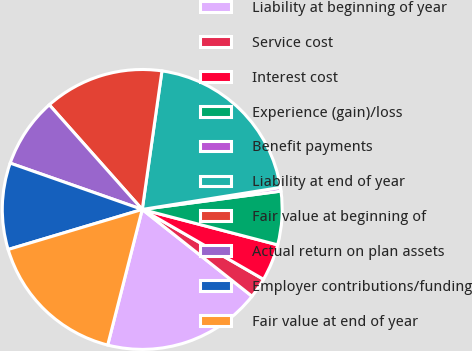Convert chart. <chart><loc_0><loc_0><loc_500><loc_500><pie_chart><fcel>Liability at beginning of year<fcel>Service cost<fcel>Interest cost<fcel>Experience (gain)/loss<fcel>Benefit payments<fcel>Liability at end of year<fcel>Fair value at beginning of<fcel>Actual return on plan assets<fcel>Employer contributions/funding<fcel>Fair value at end of year<nl><fcel>18.32%<fcel>2.33%<fcel>4.25%<fcel>6.16%<fcel>0.42%<fcel>20.24%<fcel>13.81%<fcel>8.07%<fcel>9.99%<fcel>16.41%<nl></chart> 